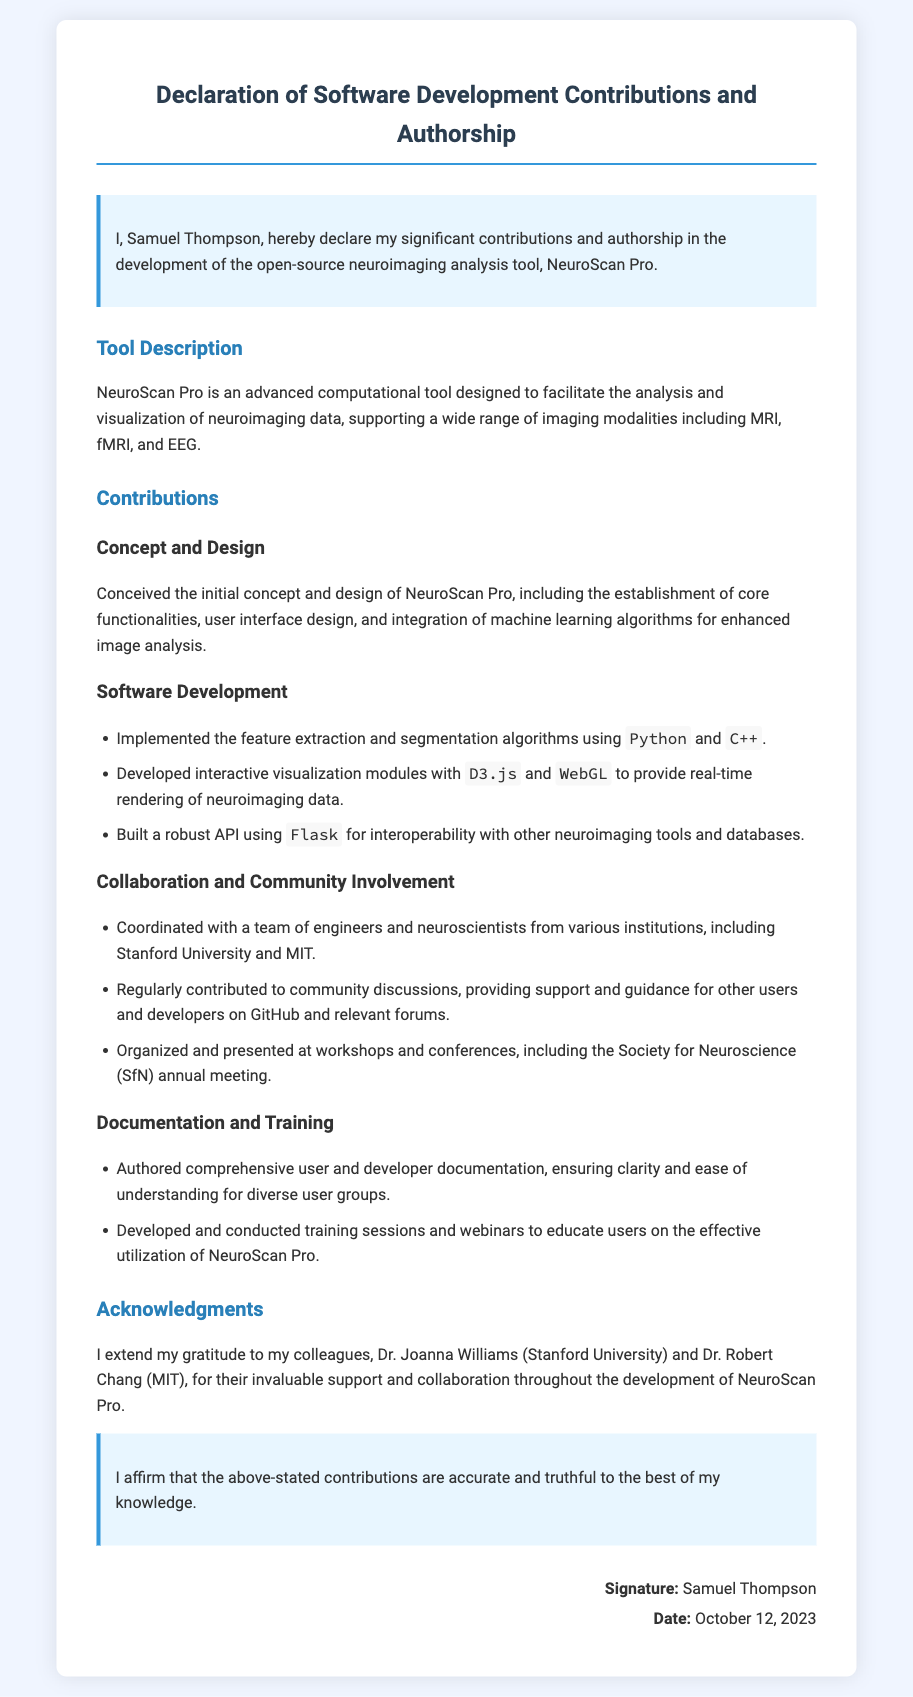What is the name of the software tool? The name of the software tool is stated clearly in the document as NeuroScan Pro.
Answer: NeuroScan Pro Who is the author of the declaration? The author of the declaration is identified at the beginning of the document as Samuel Thompson.
Answer: Samuel Thompson What is the date of the declaration? The date of the declaration is clearly mentioned towards the end of the document.
Answer: October 12, 2023 Which universities were mentioned in collaboration? The document lists specific institutions involved in collaboration, namely Stanford University and MIT.
Answer: Stanford University and MIT What programming languages were used for implementation? The programming languages mentioned in the contributions section include Python and C++.
Answer: Python and C++ How many contributions are listed under Software Development? The document provides a specific count of contributions under the Software Development section, which are three.
Answer: Three What type of tool is NeuroScan Pro described as? The document describes NeuroScan Pro as an advanced computational tool intended for a specific use.
Answer: Computational tool What does the author affirm at the end of the document? At the end of the document, the author makes a statement regarding the truthfulness of the contributions listed.
Answer: Truthful Who received acknowledgments from the author? The author expresses gratitude towards two individuals specifically named in the acknowledgments section.
Answer: Dr. Joanna Williams and Dr. Robert Chang 